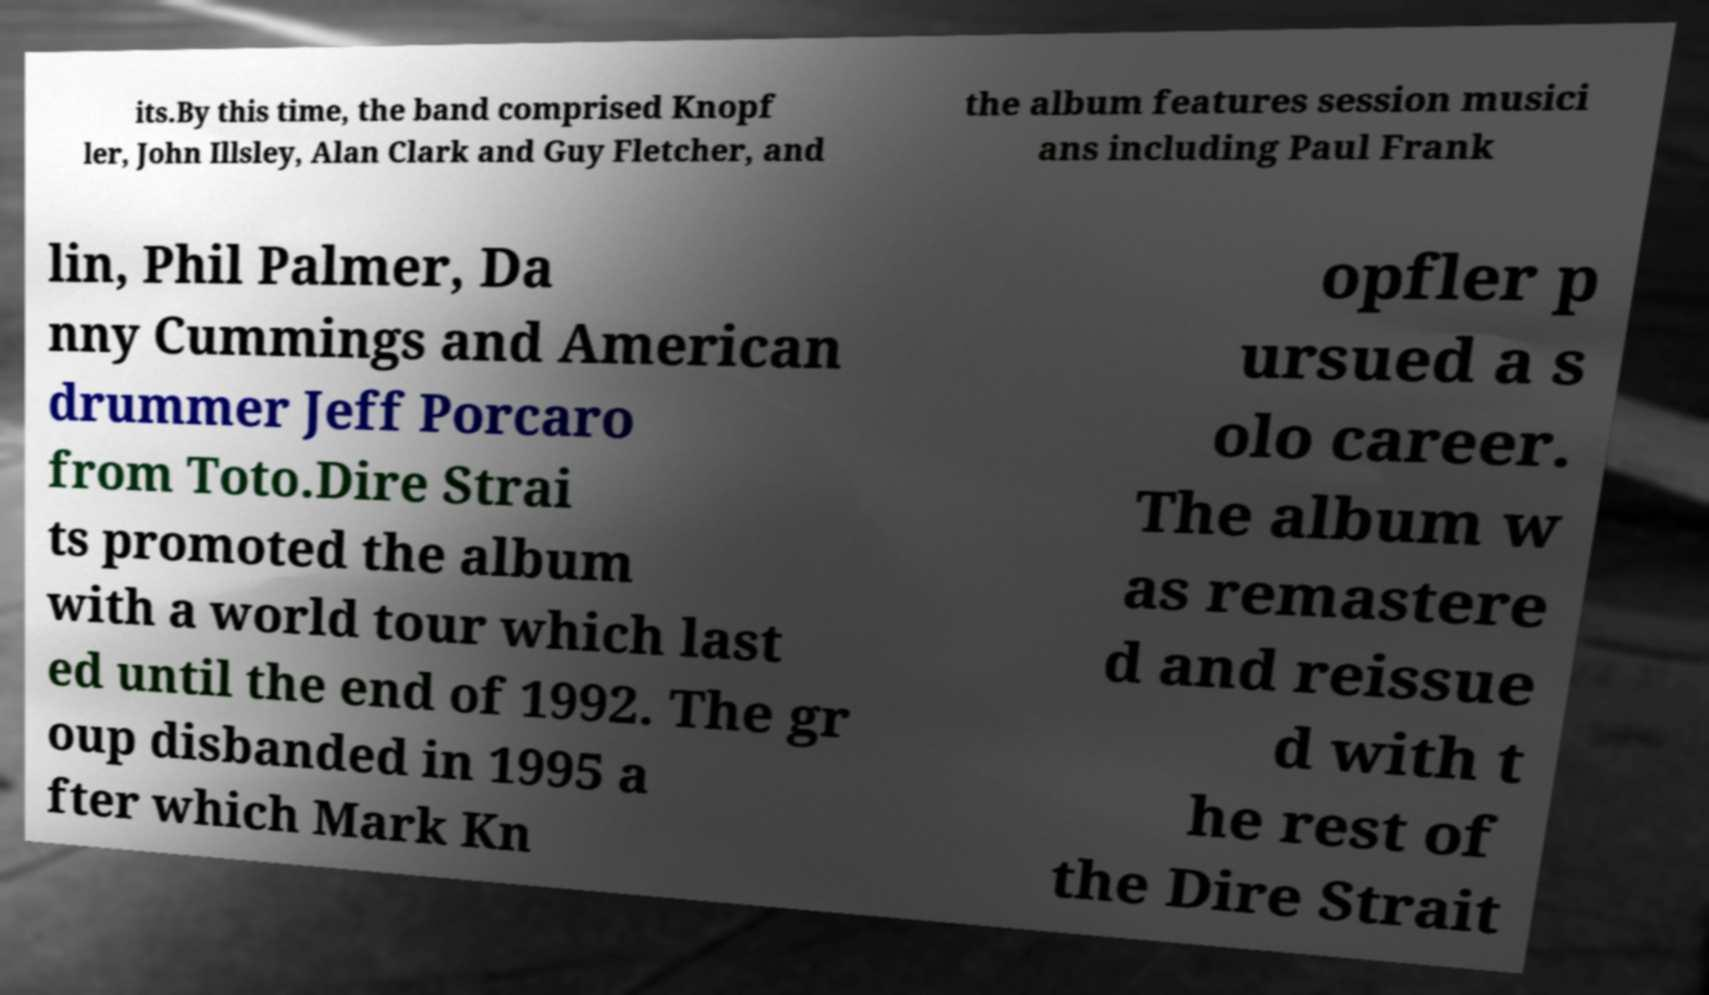Can you accurately transcribe the text from the provided image for me? its.By this time, the band comprised Knopf ler, John Illsley, Alan Clark and Guy Fletcher, and the album features session musici ans including Paul Frank lin, Phil Palmer, Da nny Cummings and American drummer Jeff Porcaro from Toto.Dire Strai ts promoted the album with a world tour which last ed until the end of 1992. The gr oup disbanded in 1995 a fter which Mark Kn opfler p ursued a s olo career. The album w as remastere d and reissue d with t he rest of the Dire Strait 